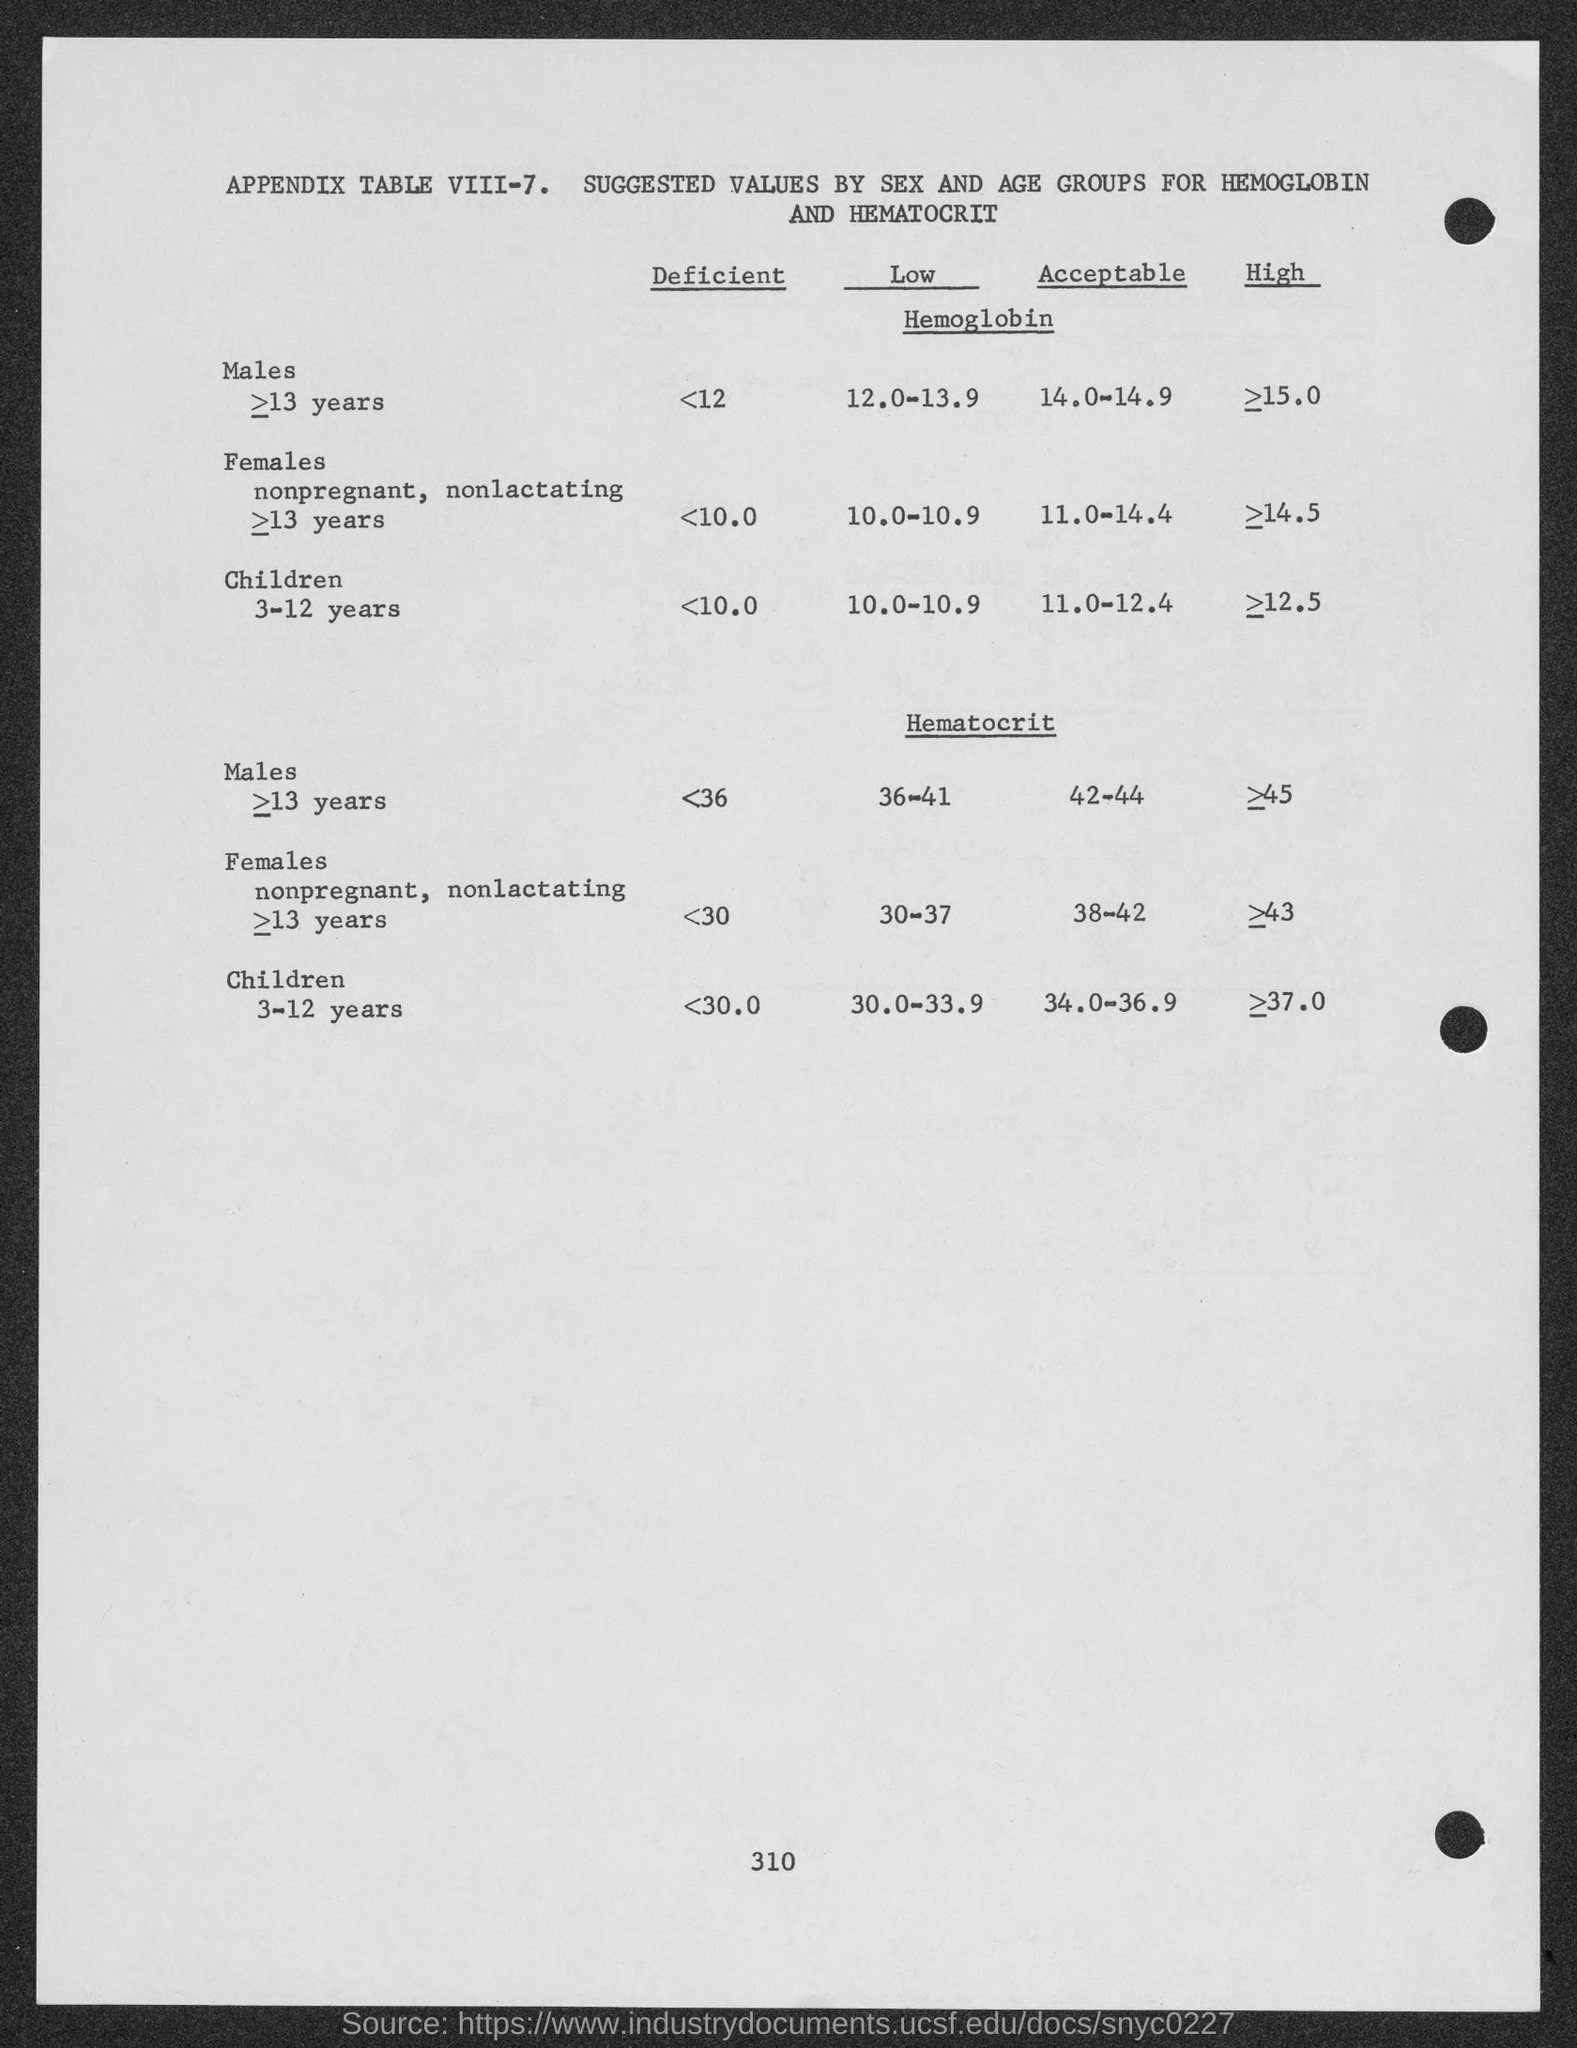What is the heading of the table ?
Offer a very short reply. Appendix table viii-7. suggested values by sex and age groups for hemoglobin and hematocrit. How many males are deficient in hemoglobin ?
Provide a short and direct response. <12. How many females are deficient in hemoglobin ?
Make the answer very short. <10.0. How many children are deficient in hemoglobin ?
Offer a terse response. <10.0. 